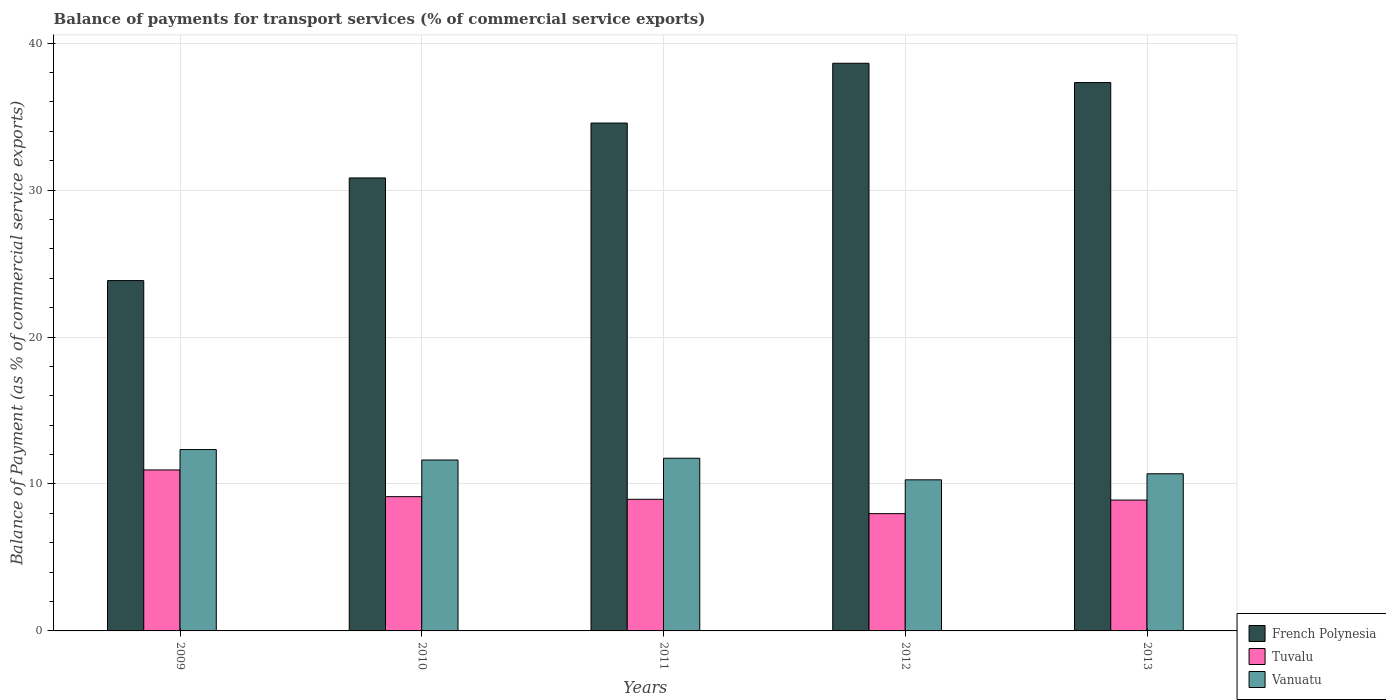How many groups of bars are there?
Your answer should be very brief. 5. Are the number of bars on each tick of the X-axis equal?
Keep it short and to the point. Yes. How many bars are there on the 5th tick from the right?
Provide a succinct answer. 3. What is the label of the 1st group of bars from the left?
Give a very brief answer. 2009. What is the balance of payments for transport services in Vanuatu in 2013?
Provide a succinct answer. 10.69. Across all years, what is the maximum balance of payments for transport services in Vanuatu?
Keep it short and to the point. 12.34. Across all years, what is the minimum balance of payments for transport services in Vanuatu?
Offer a terse response. 10.28. What is the total balance of payments for transport services in French Polynesia in the graph?
Your response must be concise. 165.18. What is the difference between the balance of payments for transport services in Vanuatu in 2009 and that in 2011?
Make the answer very short. 0.59. What is the difference between the balance of payments for transport services in Vanuatu in 2009 and the balance of payments for transport services in Tuvalu in 2013?
Your answer should be compact. 3.44. What is the average balance of payments for transport services in Vanuatu per year?
Give a very brief answer. 11.34. In the year 2012, what is the difference between the balance of payments for transport services in Vanuatu and balance of payments for transport services in French Polynesia?
Give a very brief answer. -28.35. What is the ratio of the balance of payments for transport services in French Polynesia in 2009 to that in 2013?
Your answer should be compact. 0.64. Is the balance of payments for transport services in Vanuatu in 2012 less than that in 2013?
Provide a short and direct response. Yes. Is the difference between the balance of payments for transport services in Vanuatu in 2010 and 2012 greater than the difference between the balance of payments for transport services in French Polynesia in 2010 and 2012?
Your response must be concise. Yes. What is the difference between the highest and the second highest balance of payments for transport services in Tuvalu?
Your response must be concise. 1.82. What is the difference between the highest and the lowest balance of payments for transport services in Tuvalu?
Offer a very short reply. 2.97. In how many years, is the balance of payments for transport services in Vanuatu greater than the average balance of payments for transport services in Vanuatu taken over all years?
Your answer should be very brief. 3. Is the sum of the balance of payments for transport services in Vanuatu in 2010 and 2013 greater than the maximum balance of payments for transport services in Tuvalu across all years?
Provide a short and direct response. Yes. What does the 1st bar from the left in 2012 represents?
Your answer should be compact. French Polynesia. What does the 3rd bar from the right in 2013 represents?
Ensure brevity in your answer.  French Polynesia. Is it the case that in every year, the sum of the balance of payments for transport services in French Polynesia and balance of payments for transport services in Tuvalu is greater than the balance of payments for transport services in Vanuatu?
Keep it short and to the point. Yes. How many years are there in the graph?
Keep it short and to the point. 5. Are the values on the major ticks of Y-axis written in scientific E-notation?
Keep it short and to the point. No. Does the graph contain grids?
Your response must be concise. Yes. Where does the legend appear in the graph?
Provide a short and direct response. Bottom right. How are the legend labels stacked?
Provide a short and direct response. Vertical. What is the title of the graph?
Your response must be concise. Balance of payments for transport services (% of commercial service exports). What is the label or title of the X-axis?
Keep it short and to the point. Years. What is the label or title of the Y-axis?
Make the answer very short. Balance of Payment (as % of commercial service exports). What is the Balance of Payment (as % of commercial service exports) of French Polynesia in 2009?
Keep it short and to the point. 23.84. What is the Balance of Payment (as % of commercial service exports) of Tuvalu in 2009?
Offer a very short reply. 10.96. What is the Balance of Payment (as % of commercial service exports) of Vanuatu in 2009?
Ensure brevity in your answer.  12.34. What is the Balance of Payment (as % of commercial service exports) in French Polynesia in 2010?
Your response must be concise. 30.83. What is the Balance of Payment (as % of commercial service exports) in Tuvalu in 2010?
Your answer should be compact. 9.14. What is the Balance of Payment (as % of commercial service exports) of Vanuatu in 2010?
Your response must be concise. 11.63. What is the Balance of Payment (as % of commercial service exports) in French Polynesia in 2011?
Offer a very short reply. 34.56. What is the Balance of Payment (as % of commercial service exports) of Tuvalu in 2011?
Provide a short and direct response. 8.96. What is the Balance of Payment (as % of commercial service exports) in Vanuatu in 2011?
Give a very brief answer. 11.75. What is the Balance of Payment (as % of commercial service exports) of French Polynesia in 2012?
Make the answer very short. 38.63. What is the Balance of Payment (as % of commercial service exports) in Tuvalu in 2012?
Your response must be concise. 7.98. What is the Balance of Payment (as % of commercial service exports) of Vanuatu in 2012?
Provide a succinct answer. 10.28. What is the Balance of Payment (as % of commercial service exports) of French Polynesia in 2013?
Your answer should be compact. 37.32. What is the Balance of Payment (as % of commercial service exports) of Tuvalu in 2013?
Offer a very short reply. 8.91. What is the Balance of Payment (as % of commercial service exports) of Vanuatu in 2013?
Provide a succinct answer. 10.69. Across all years, what is the maximum Balance of Payment (as % of commercial service exports) in French Polynesia?
Give a very brief answer. 38.63. Across all years, what is the maximum Balance of Payment (as % of commercial service exports) of Tuvalu?
Offer a very short reply. 10.96. Across all years, what is the maximum Balance of Payment (as % of commercial service exports) in Vanuatu?
Offer a very short reply. 12.34. Across all years, what is the minimum Balance of Payment (as % of commercial service exports) in French Polynesia?
Offer a very short reply. 23.84. Across all years, what is the minimum Balance of Payment (as % of commercial service exports) in Tuvalu?
Ensure brevity in your answer.  7.98. Across all years, what is the minimum Balance of Payment (as % of commercial service exports) of Vanuatu?
Give a very brief answer. 10.28. What is the total Balance of Payment (as % of commercial service exports) of French Polynesia in the graph?
Offer a very short reply. 165.18. What is the total Balance of Payment (as % of commercial service exports) of Tuvalu in the graph?
Make the answer very short. 45.94. What is the total Balance of Payment (as % of commercial service exports) in Vanuatu in the graph?
Your answer should be compact. 56.7. What is the difference between the Balance of Payment (as % of commercial service exports) of French Polynesia in 2009 and that in 2010?
Your response must be concise. -6.99. What is the difference between the Balance of Payment (as % of commercial service exports) in Tuvalu in 2009 and that in 2010?
Your answer should be very brief. 1.82. What is the difference between the Balance of Payment (as % of commercial service exports) in Vanuatu in 2009 and that in 2010?
Provide a short and direct response. 0.71. What is the difference between the Balance of Payment (as % of commercial service exports) in French Polynesia in 2009 and that in 2011?
Your response must be concise. -10.72. What is the difference between the Balance of Payment (as % of commercial service exports) in Tuvalu in 2009 and that in 2011?
Keep it short and to the point. 2. What is the difference between the Balance of Payment (as % of commercial service exports) of Vanuatu in 2009 and that in 2011?
Make the answer very short. 0.59. What is the difference between the Balance of Payment (as % of commercial service exports) of French Polynesia in 2009 and that in 2012?
Keep it short and to the point. -14.79. What is the difference between the Balance of Payment (as % of commercial service exports) in Tuvalu in 2009 and that in 2012?
Ensure brevity in your answer.  2.97. What is the difference between the Balance of Payment (as % of commercial service exports) in Vanuatu in 2009 and that in 2012?
Ensure brevity in your answer.  2.06. What is the difference between the Balance of Payment (as % of commercial service exports) in French Polynesia in 2009 and that in 2013?
Make the answer very short. -13.48. What is the difference between the Balance of Payment (as % of commercial service exports) in Tuvalu in 2009 and that in 2013?
Offer a very short reply. 2.05. What is the difference between the Balance of Payment (as % of commercial service exports) of Vanuatu in 2009 and that in 2013?
Ensure brevity in your answer.  1.65. What is the difference between the Balance of Payment (as % of commercial service exports) of French Polynesia in 2010 and that in 2011?
Give a very brief answer. -3.74. What is the difference between the Balance of Payment (as % of commercial service exports) in Tuvalu in 2010 and that in 2011?
Your answer should be compact. 0.18. What is the difference between the Balance of Payment (as % of commercial service exports) of Vanuatu in 2010 and that in 2011?
Make the answer very short. -0.12. What is the difference between the Balance of Payment (as % of commercial service exports) in French Polynesia in 2010 and that in 2012?
Make the answer very short. -7.8. What is the difference between the Balance of Payment (as % of commercial service exports) in Tuvalu in 2010 and that in 2012?
Your answer should be compact. 1.16. What is the difference between the Balance of Payment (as % of commercial service exports) in Vanuatu in 2010 and that in 2012?
Offer a very short reply. 1.35. What is the difference between the Balance of Payment (as % of commercial service exports) in French Polynesia in 2010 and that in 2013?
Your answer should be very brief. -6.49. What is the difference between the Balance of Payment (as % of commercial service exports) in Tuvalu in 2010 and that in 2013?
Your answer should be very brief. 0.23. What is the difference between the Balance of Payment (as % of commercial service exports) of Vanuatu in 2010 and that in 2013?
Offer a very short reply. 0.94. What is the difference between the Balance of Payment (as % of commercial service exports) in French Polynesia in 2011 and that in 2012?
Your answer should be very brief. -4.07. What is the difference between the Balance of Payment (as % of commercial service exports) of Tuvalu in 2011 and that in 2012?
Make the answer very short. 0.98. What is the difference between the Balance of Payment (as % of commercial service exports) of Vanuatu in 2011 and that in 2012?
Offer a terse response. 1.47. What is the difference between the Balance of Payment (as % of commercial service exports) in French Polynesia in 2011 and that in 2013?
Make the answer very short. -2.75. What is the difference between the Balance of Payment (as % of commercial service exports) in Tuvalu in 2011 and that in 2013?
Keep it short and to the point. 0.05. What is the difference between the Balance of Payment (as % of commercial service exports) in Vanuatu in 2011 and that in 2013?
Offer a very short reply. 1.06. What is the difference between the Balance of Payment (as % of commercial service exports) of French Polynesia in 2012 and that in 2013?
Your answer should be very brief. 1.31. What is the difference between the Balance of Payment (as % of commercial service exports) in Tuvalu in 2012 and that in 2013?
Ensure brevity in your answer.  -0.92. What is the difference between the Balance of Payment (as % of commercial service exports) of Vanuatu in 2012 and that in 2013?
Offer a terse response. -0.41. What is the difference between the Balance of Payment (as % of commercial service exports) of French Polynesia in 2009 and the Balance of Payment (as % of commercial service exports) of Tuvalu in 2010?
Keep it short and to the point. 14.71. What is the difference between the Balance of Payment (as % of commercial service exports) of French Polynesia in 2009 and the Balance of Payment (as % of commercial service exports) of Vanuatu in 2010?
Keep it short and to the point. 12.21. What is the difference between the Balance of Payment (as % of commercial service exports) in Tuvalu in 2009 and the Balance of Payment (as % of commercial service exports) in Vanuatu in 2010?
Give a very brief answer. -0.68. What is the difference between the Balance of Payment (as % of commercial service exports) in French Polynesia in 2009 and the Balance of Payment (as % of commercial service exports) in Tuvalu in 2011?
Your answer should be compact. 14.88. What is the difference between the Balance of Payment (as % of commercial service exports) of French Polynesia in 2009 and the Balance of Payment (as % of commercial service exports) of Vanuatu in 2011?
Offer a terse response. 12.09. What is the difference between the Balance of Payment (as % of commercial service exports) of Tuvalu in 2009 and the Balance of Payment (as % of commercial service exports) of Vanuatu in 2011?
Your answer should be compact. -0.8. What is the difference between the Balance of Payment (as % of commercial service exports) in French Polynesia in 2009 and the Balance of Payment (as % of commercial service exports) in Tuvalu in 2012?
Your answer should be very brief. 15.86. What is the difference between the Balance of Payment (as % of commercial service exports) in French Polynesia in 2009 and the Balance of Payment (as % of commercial service exports) in Vanuatu in 2012?
Your response must be concise. 13.56. What is the difference between the Balance of Payment (as % of commercial service exports) of Tuvalu in 2009 and the Balance of Payment (as % of commercial service exports) of Vanuatu in 2012?
Give a very brief answer. 0.67. What is the difference between the Balance of Payment (as % of commercial service exports) of French Polynesia in 2009 and the Balance of Payment (as % of commercial service exports) of Tuvalu in 2013?
Offer a very short reply. 14.94. What is the difference between the Balance of Payment (as % of commercial service exports) in French Polynesia in 2009 and the Balance of Payment (as % of commercial service exports) in Vanuatu in 2013?
Your answer should be very brief. 13.15. What is the difference between the Balance of Payment (as % of commercial service exports) of Tuvalu in 2009 and the Balance of Payment (as % of commercial service exports) of Vanuatu in 2013?
Provide a succinct answer. 0.26. What is the difference between the Balance of Payment (as % of commercial service exports) in French Polynesia in 2010 and the Balance of Payment (as % of commercial service exports) in Tuvalu in 2011?
Ensure brevity in your answer.  21.87. What is the difference between the Balance of Payment (as % of commercial service exports) of French Polynesia in 2010 and the Balance of Payment (as % of commercial service exports) of Vanuatu in 2011?
Your answer should be very brief. 19.08. What is the difference between the Balance of Payment (as % of commercial service exports) of Tuvalu in 2010 and the Balance of Payment (as % of commercial service exports) of Vanuatu in 2011?
Keep it short and to the point. -2.61. What is the difference between the Balance of Payment (as % of commercial service exports) of French Polynesia in 2010 and the Balance of Payment (as % of commercial service exports) of Tuvalu in 2012?
Your answer should be compact. 22.85. What is the difference between the Balance of Payment (as % of commercial service exports) in French Polynesia in 2010 and the Balance of Payment (as % of commercial service exports) in Vanuatu in 2012?
Provide a short and direct response. 20.54. What is the difference between the Balance of Payment (as % of commercial service exports) of Tuvalu in 2010 and the Balance of Payment (as % of commercial service exports) of Vanuatu in 2012?
Ensure brevity in your answer.  -1.15. What is the difference between the Balance of Payment (as % of commercial service exports) of French Polynesia in 2010 and the Balance of Payment (as % of commercial service exports) of Tuvalu in 2013?
Provide a short and direct response. 21.92. What is the difference between the Balance of Payment (as % of commercial service exports) of French Polynesia in 2010 and the Balance of Payment (as % of commercial service exports) of Vanuatu in 2013?
Offer a terse response. 20.13. What is the difference between the Balance of Payment (as % of commercial service exports) of Tuvalu in 2010 and the Balance of Payment (as % of commercial service exports) of Vanuatu in 2013?
Provide a short and direct response. -1.56. What is the difference between the Balance of Payment (as % of commercial service exports) of French Polynesia in 2011 and the Balance of Payment (as % of commercial service exports) of Tuvalu in 2012?
Ensure brevity in your answer.  26.58. What is the difference between the Balance of Payment (as % of commercial service exports) of French Polynesia in 2011 and the Balance of Payment (as % of commercial service exports) of Vanuatu in 2012?
Your answer should be compact. 24.28. What is the difference between the Balance of Payment (as % of commercial service exports) in Tuvalu in 2011 and the Balance of Payment (as % of commercial service exports) in Vanuatu in 2012?
Give a very brief answer. -1.33. What is the difference between the Balance of Payment (as % of commercial service exports) of French Polynesia in 2011 and the Balance of Payment (as % of commercial service exports) of Tuvalu in 2013?
Offer a terse response. 25.66. What is the difference between the Balance of Payment (as % of commercial service exports) in French Polynesia in 2011 and the Balance of Payment (as % of commercial service exports) in Vanuatu in 2013?
Your answer should be compact. 23.87. What is the difference between the Balance of Payment (as % of commercial service exports) in Tuvalu in 2011 and the Balance of Payment (as % of commercial service exports) in Vanuatu in 2013?
Keep it short and to the point. -1.74. What is the difference between the Balance of Payment (as % of commercial service exports) of French Polynesia in 2012 and the Balance of Payment (as % of commercial service exports) of Tuvalu in 2013?
Your answer should be very brief. 29.73. What is the difference between the Balance of Payment (as % of commercial service exports) of French Polynesia in 2012 and the Balance of Payment (as % of commercial service exports) of Vanuatu in 2013?
Offer a very short reply. 27.94. What is the difference between the Balance of Payment (as % of commercial service exports) in Tuvalu in 2012 and the Balance of Payment (as % of commercial service exports) in Vanuatu in 2013?
Provide a short and direct response. -2.71. What is the average Balance of Payment (as % of commercial service exports) of French Polynesia per year?
Your response must be concise. 33.04. What is the average Balance of Payment (as % of commercial service exports) of Tuvalu per year?
Your answer should be very brief. 9.19. What is the average Balance of Payment (as % of commercial service exports) in Vanuatu per year?
Your answer should be very brief. 11.34. In the year 2009, what is the difference between the Balance of Payment (as % of commercial service exports) in French Polynesia and Balance of Payment (as % of commercial service exports) in Tuvalu?
Keep it short and to the point. 12.89. In the year 2009, what is the difference between the Balance of Payment (as % of commercial service exports) in French Polynesia and Balance of Payment (as % of commercial service exports) in Vanuatu?
Offer a very short reply. 11.5. In the year 2009, what is the difference between the Balance of Payment (as % of commercial service exports) in Tuvalu and Balance of Payment (as % of commercial service exports) in Vanuatu?
Provide a short and direct response. -1.39. In the year 2010, what is the difference between the Balance of Payment (as % of commercial service exports) of French Polynesia and Balance of Payment (as % of commercial service exports) of Tuvalu?
Offer a terse response. 21.69. In the year 2010, what is the difference between the Balance of Payment (as % of commercial service exports) in French Polynesia and Balance of Payment (as % of commercial service exports) in Vanuatu?
Keep it short and to the point. 19.2. In the year 2010, what is the difference between the Balance of Payment (as % of commercial service exports) in Tuvalu and Balance of Payment (as % of commercial service exports) in Vanuatu?
Your answer should be very brief. -2.49. In the year 2011, what is the difference between the Balance of Payment (as % of commercial service exports) of French Polynesia and Balance of Payment (as % of commercial service exports) of Tuvalu?
Your response must be concise. 25.61. In the year 2011, what is the difference between the Balance of Payment (as % of commercial service exports) in French Polynesia and Balance of Payment (as % of commercial service exports) in Vanuatu?
Ensure brevity in your answer.  22.81. In the year 2011, what is the difference between the Balance of Payment (as % of commercial service exports) of Tuvalu and Balance of Payment (as % of commercial service exports) of Vanuatu?
Your response must be concise. -2.79. In the year 2012, what is the difference between the Balance of Payment (as % of commercial service exports) of French Polynesia and Balance of Payment (as % of commercial service exports) of Tuvalu?
Keep it short and to the point. 30.65. In the year 2012, what is the difference between the Balance of Payment (as % of commercial service exports) of French Polynesia and Balance of Payment (as % of commercial service exports) of Vanuatu?
Your answer should be compact. 28.35. In the year 2012, what is the difference between the Balance of Payment (as % of commercial service exports) in Tuvalu and Balance of Payment (as % of commercial service exports) in Vanuatu?
Offer a very short reply. -2.3. In the year 2013, what is the difference between the Balance of Payment (as % of commercial service exports) of French Polynesia and Balance of Payment (as % of commercial service exports) of Tuvalu?
Your response must be concise. 28.41. In the year 2013, what is the difference between the Balance of Payment (as % of commercial service exports) in French Polynesia and Balance of Payment (as % of commercial service exports) in Vanuatu?
Provide a succinct answer. 26.62. In the year 2013, what is the difference between the Balance of Payment (as % of commercial service exports) in Tuvalu and Balance of Payment (as % of commercial service exports) in Vanuatu?
Give a very brief answer. -1.79. What is the ratio of the Balance of Payment (as % of commercial service exports) of French Polynesia in 2009 to that in 2010?
Offer a very short reply. 0.77. What is the ratio of the Balance of Payment (as % of commercial service exports) in Tuvalu in 2009 to that in 2010?
Make the answer very short. 1.2. What is the ratio of the Balance of Payment (as % of commercial service exports) of Vanuatu in 2009 to that in 2010?
Provide a succinct answer. 1.06. What is the ratio of the Balance of Payment (as % of commercial service exports) of French Polynesia in 2009 to that in 2011?
Ensure brevity in your answer.  0.69. What is the ratio of the Balance of Payment (as % of commercial service exports) of Tuvalu in 2009 to that in 2011?
Make the answer very short. 1.22. What is the ratio of the Balance of Payment (as % of commercial service exports) in Vanuatu in 2009 to that in 2011?
Your answer should be compact. 1.05. What is the ratio of the Balance of Payment (as % of commercial service exports) of French Polynesia in 2009 to that in 2012?
Give a very brief answer. 0.62. What is the ratio of the Balance of Payment (as % of commercial service exports) in Tuvalu in 2009 to that in 2012?
Your answer should be compact. 1.37. What is the ratio of the Balance of Payment (as % of commercial service exports) in Vanuatu in 2009 to that in 2012?
Your response must be concise. 1.2. What is the ratio of the Balance of Payment (as % of commercial service exports) of French Polynesia in 2009 to that in 2013?
Your answer should be compact. 0.64. What is the ratio of the Balance of Payment (as % of commercial service exports) in Tuvalu in 2009 to that in 2013?
Provide a succinct answer. 1.23. What is the ratio of the Balance of Payment (as % of commercial service exports) in Vanuatu in 2009 to that in 2013?
Provide a short and direct response. 1.15. What is the ratio of the Balance of Payment (as % of commercial service exports) in French Polynesia in 2010 to that in 2011?
Your answer should be compact. 0.89. What is the ratio of the Balance of Payment (as % of commercial service exports) of Vanuatu in 2010 to that in 2011?
Your answer should be compact. 0.99. What is the ratio of the Balance of Payment (as % of commercial service exports) in French Polynesia in 2010 to that in 2012?
Provide a short and direct response. 0.8. What is the ratio of the Balance of Payment (as % of commercial service exports) of Tuvalu in 2010 to that in 2012?
Your response must be concise. 1.14. What is the ratio of the Balance of Payment (as % of commercial service exports) of Vanuatu in 2010 to that in 2012?
Offer a very short reply. 1.13. What is the ratio of the Balance of Payment (as % of commercial service exports) of French Polynesia in 2010 to that in 2013?
Ensure brevity in your answer.  0.83. What is the ratio of the Balance of Payment (as % of commercial service exports) in Tuvalu in 2010 to that in 2013?
Keep it short and to the point. 1.03. What is the ratio of the Balance of Payment (as % of commercial service exports) of Vanuatu in 2010 to that in 2013?
Give a very brief answer. 1.09. What is the ratio of the Balance of Payment (as % of commercial service exports) of French Polynesia in 2011 to that in 2012?
Give a very brief answer. 0.89. What is the ratio of the Balance of Payment (as % of commercial service exports) of Tuvalu in 2011 to that in 2012?
Make the answer very short. 1.12. What is the ratio of the Balance of Payment (as % of commercial service exports) of Vanuatu in 2011 to that in 2012?
Ensure brevity in your answer.  1.14. What is the ratio of the Balance of Payment (as % of commercial service exports) of French Polynesia in 2011 to that in 2013?
Provide a succinct answer. 0.93. What is the ratio of the Balance of Payment (as % of commercial service exports) in Tuvalu in 2011 to that in 2013?
Give a very brief answer. 1.01. What is the ratio of the Balance of Payment (as % of commercial service exports) of Vanuatu in 2011 to that in 2013?
Offer a terse response. 1.1. What is the ratio of the Balance of Payment (as % of commercial service exports) of French Polynesia in 2012 to that in 2013?
Your answer should be very brief. 1.04. What is the ratio of the Balance of Payment (as % of commercial service exports) of Tuvalu in 2012 to that in 2013?
Keep it short and to the point. 0.9. What is the ratio of the Balance of Payment (as % of commercial service exports) in Vanuatu in 2012 to that in 2013?
Provide a succinct answer. 0.96. What is the difference between the highest and the second highest Balance of Payment (as % of commercial service exports) in French Polynesia?
Your answer should be compact. 1.31. What is the difference between the highest and the second highest Balance of Payment (as % of commercial service exports) of Tuvalu?
Offer a terse response. 1.82. What is the difference between the highest and the second highest Balance of Payment (as % of commercial service exports) in Vanuatu?
Your answer should be very brief. 0.59. What is the difference between the highest and the lowest Balance of Payment (as % of commercial service exports) of French Polynesia?
Your response must be concise. 14.79. What is the difference between the highest and the lowest Balance of Payment (as % of commercial service exports) in Tuvalu?
Give a very brief answer. 2.97. What is the difference between the highest and the lowest Balance of Payment (as % of commercial service exports) of Vanuatu?
Make the answer very short. 2.06. 